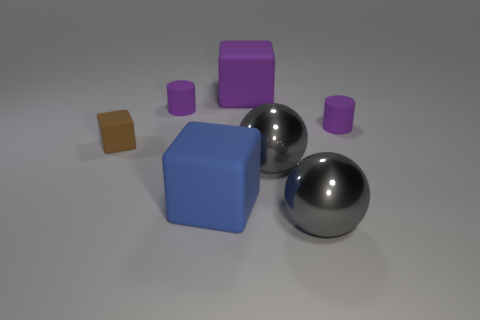Add 2 large spheres. How many objects exist? 9 Subtract all blocks. How many objects are left? 4 Add 7 large rubber things. How many large rubber things are left? 9 Add 5 brown things. How many brown things exist? 6 Subtract 1 purple cylinders. How many objects are left? 6 Subtract all cylinders. Subtract all big gray shiny spheres. How many objects are left? 3 